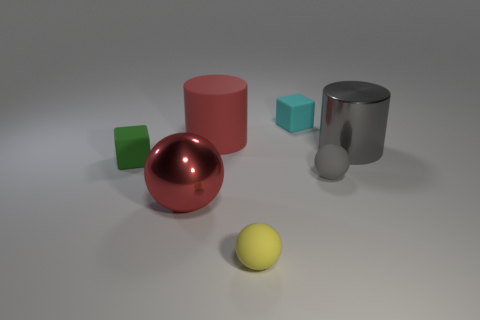Subtract all tiny yellow matte spheres. How many spheres are left? 2 Subtract all blocks. How many objects are left? 5 Subtract all gray spheres. How many spheres are left? 2 Subtract 0 brown cylinders. How many objects are left? 7 Subtract 3 spheres. How many spheres are left? 0 Subtract all brown cylinders. Subtract all brown balls. How many cylinders are left? 2 Subtract all purple cylinders. How many yellow spheres are left? 1 Subtract all green rubber objects. Subtract all cyan rubber things. How many objects are left? 5 Add 5 small gray balls. How many small gray balls are left? 6 Add 1 blue cylinders. How many blue cylinders exist? 1 